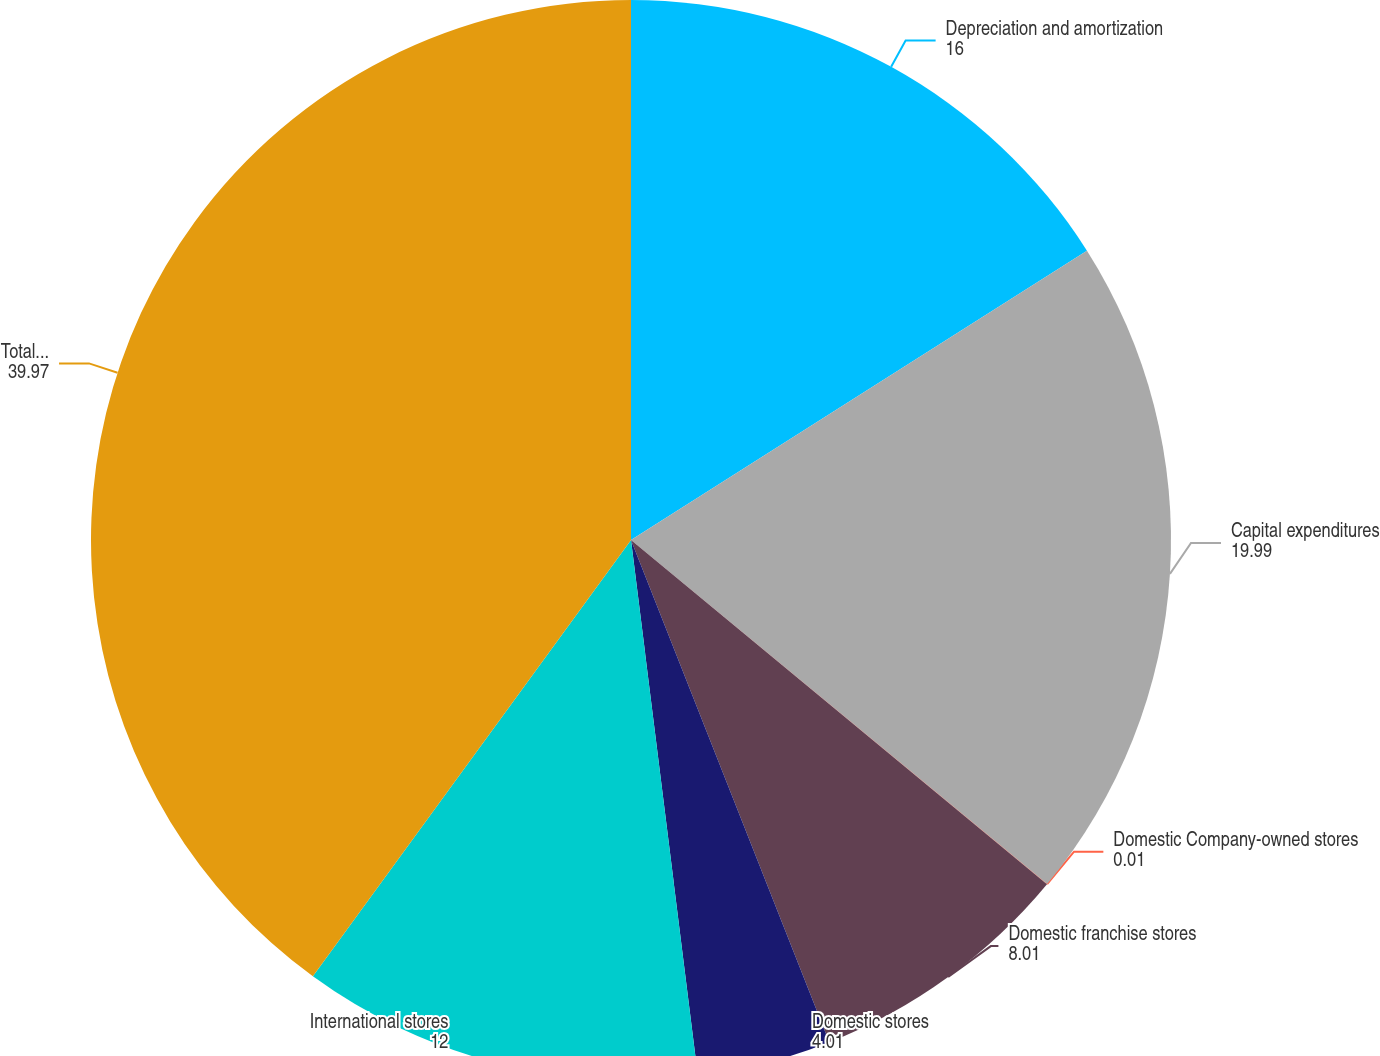<chart> <loc_0><loc_0><loc_500><loc_500><pie_chart><fcel>Depreciation and amortization<fcel>Capital expenditures<fcel>Domestic Company-owned stores<fcel>Domestic franchise stores<fcel>Domestic stores<fcel>International stores<fcel>Total stores<nl><fcel>16.0%<fcel>19.99%<fcel>0.01%<fcel>8.01%<fcel>4.01%<fcel>12.0%<fcel>39.97%<nl></chart> 